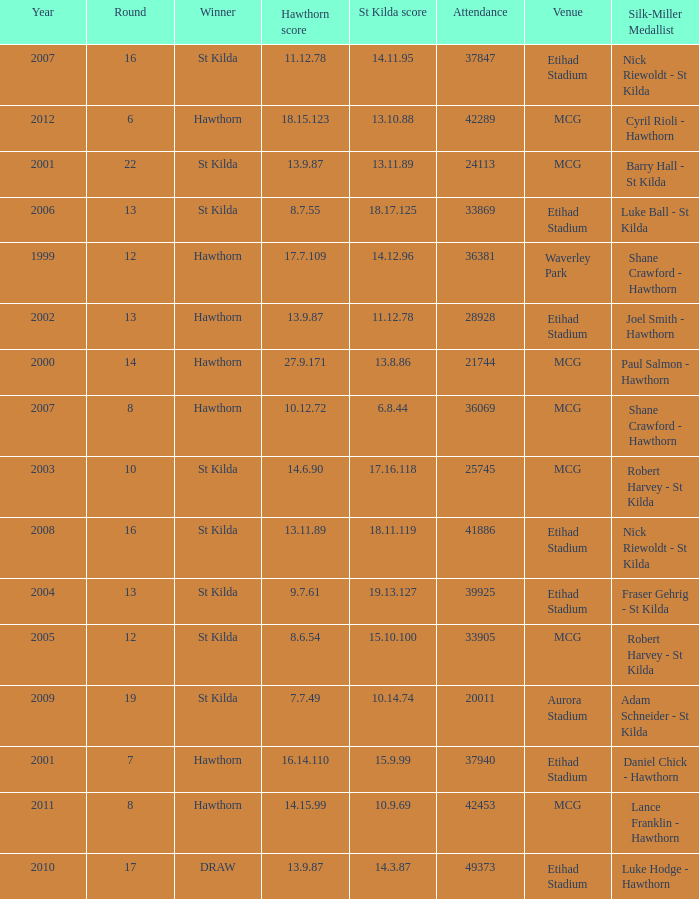What is the attendance when the hawthorn score is 18.15.123? 42289.0. 